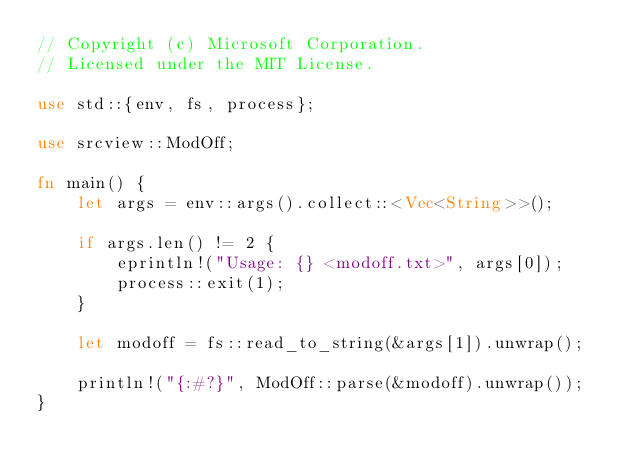Convert code to text. <code><loc_0><loc_0><loc_500><loc_500><_Rust_>// Copyright (c) Microsoft Corporation.
// Licensed under the MIT License.

use std::{env, fs, process};

use srcview::ModOff;

fn main() {
    let args = env::args().collect::<Vec<String>>();

    if args.len() != 2 {
        eprintln!("Usage: {} <modoff.txt>", args[0]);
        process::exit(1);
    }

    let modoff = fs::read_to_string(&args[1]).unwrap();

    println!("{:#?}", ModOff::parse(&modoff).unwrap());
}
</code> 